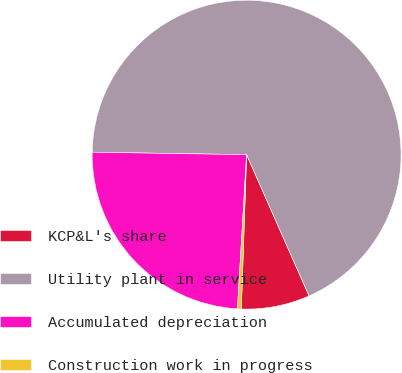Convert chart to OTSL. <chart><loc_0><loc_0><loc_500><loc_500><pie_chart><fcel>KCP&L's share<fcel>Utility plant in service<fcel>Accumulated depreciation<fcel>Construction work in progress<nl><fcel>7.17%<fcel>68.12%<fcel>24.31%<fcel>0.4%<nl></chart> 